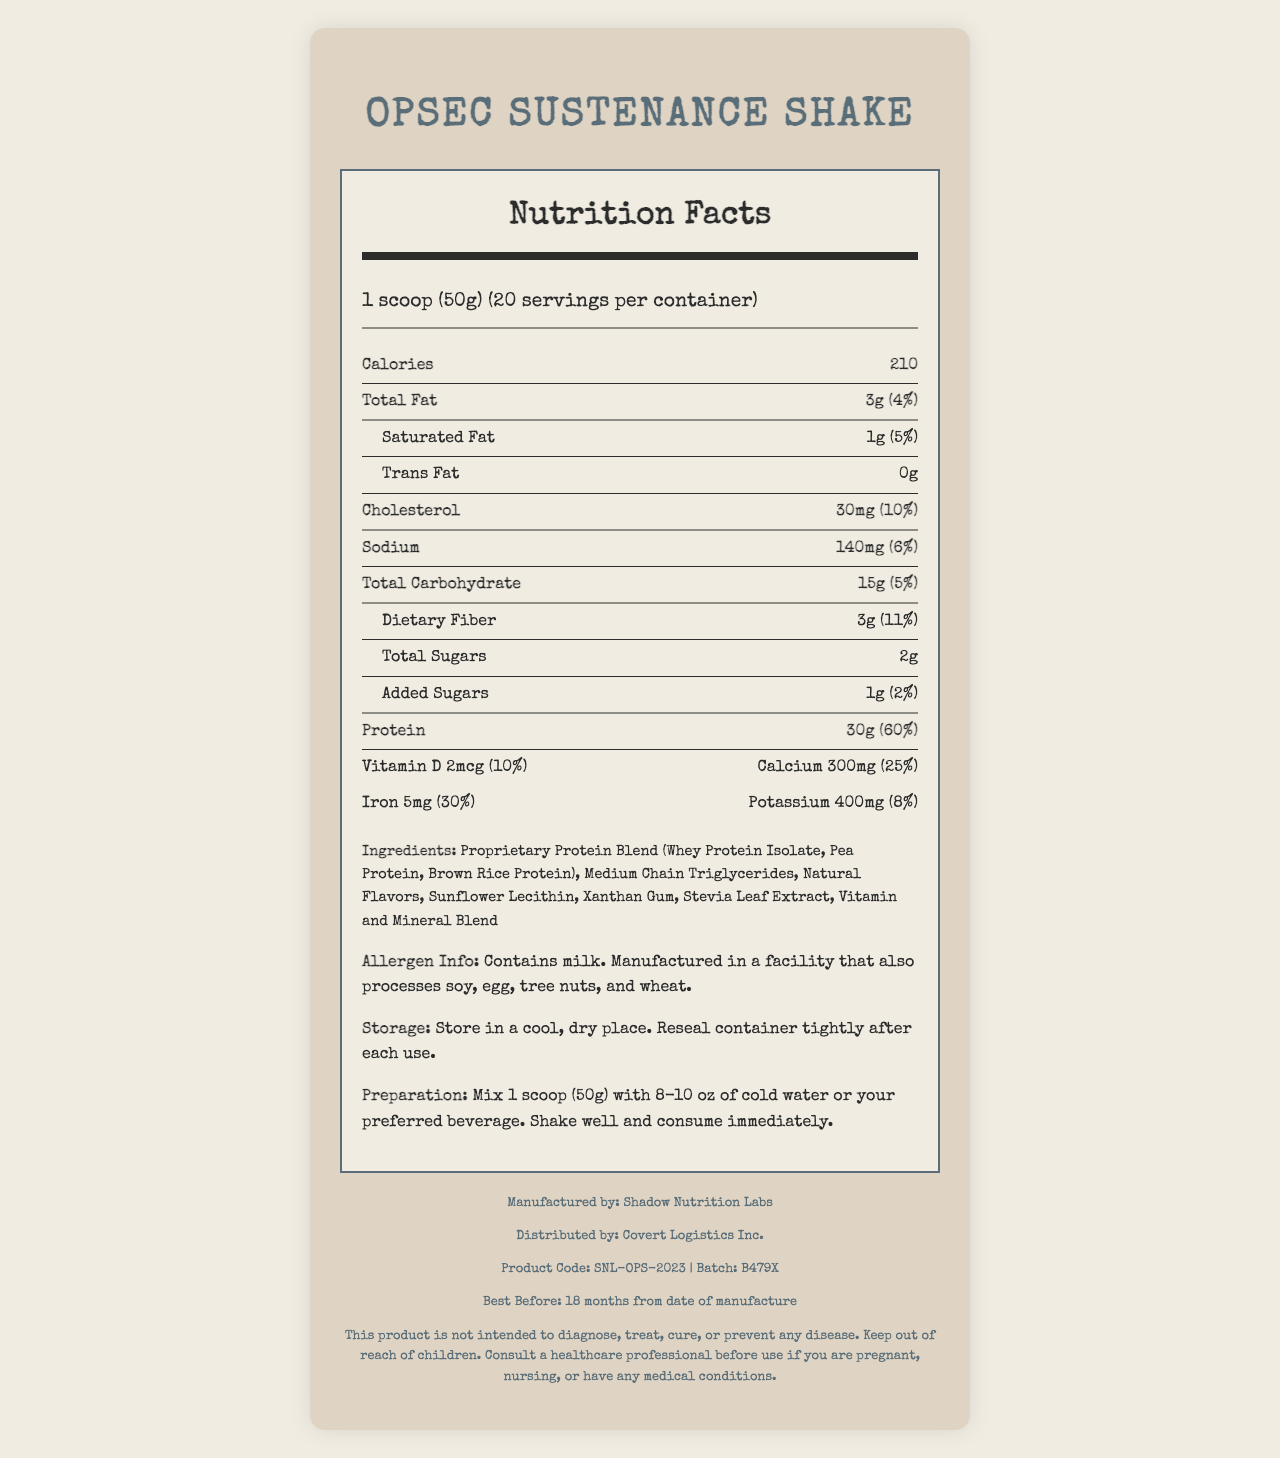what is the serving size for the OpSec Sustenance Shake? The serving size is stated as "1 scoop (50g)" in the serving info section.
Answer: 1 scoop (50g) how many servings are in one container of the OpSec Sustenance Shake? The document specifies that there are 20 servings per container.
Answer: 20 how many calories are in one serving of the OpSec Sustenance Shake? According to the bolded nutrient row, each serving contains 210 calories.
Answer: 210 what is the protein content in one serving of the OpSec Sustenance Shake? The protein content is listed as 30g in the bolded nutrient row for protein.
Answer: 30g what is the daily percentage value of vitamin B12 in this shake? The document states that the daily value percentage for vitamin B12 is 80%.
Answer: 80% which ingredient is not in the OpSec Sustenance Shake? A. Medium Chain Triglycerides B. Xanthan Gum C. Sucrose D. Stevia Leaf Extract The ingredients listed are Proprietary Protein Blend, Medium Chain Triglycerides, Natural Flavors, Sunflower Lecithin, Xanthan Gum, Stevia Leaf Extract, and Vitamin and Mineral Blend. Sucrose is not mentioned.
Answer: C what is the daily percentage value of vitamin E in one serving of the shake? The daily value percentage for vitamin E is noted as 70% in the vitamin-mineral section.
Answer: 70% does the OpSec Sustenance Shake contain added sugars? The document specifies that there are 1g of added sugars, which is 2% of the daily value.
Answer: Yes what is the company name that manufactures this product? According to the footer information, this product is manufactured by Shadow Nutrition Labs.
Answer: Shadow Nutrition Labs is there any trans fat in one serving of the OpSec Sustenance Shake? The document states that the amount of trans fat is 0g.
Answer: No describe the document's primary purpose and the kind of information it provides The document's primary purpose is to offer consumers detailed nutrition information for the OpSec Sustenance Shake. It lists all key nutrients, ingredients, and additional product information to help users understand its contents and how to use it.
Answer: The document serves as a Nutrition Facts Label for the OpSec Sustenance Shake. It provides comprehensive information about serving size, number of servings, and detailed nutrient content per serving, including macronutrients, vitamins, and minerals. The document also includes an ingredient list, allergen information, storage and preparation instructions, and manufacturer details. who is the distributor for the OpSec Sustenance Shake? The footer section of the document lists Covert Logistics Inc. as the distributor.
Answer: Covert Logistics Inc. what is the expiration date of the OpSec Sustenance Shake? The expiration date is given as "18 months from date of manufacture" in the footer.
Answer: 18 months from date of manufacture what is the total carbohydrate content of the OpSec Sustenance Shake? A. 10g B. 15g C. 20g D. 25g The document lists the total carbohydrate content as 15g.
Answer: B does the shake contain ingredients derived from tree nuts? The allergen info mentions that the product is manufactured in a facility that processes tree nuts, but it does not specify whether tree nuts are used in the shake itself.
Answer: Not enough information what is the amount of cholesterol in one serving? The document specifies that one serving contains 30mg of cholesterol.
Answer: 30mg how should this product be stored? The storage instructions section provides this storage information.
Answer: Store in a cool, dry place. Reseal container tightly after each use. what is the reason for consulting a healthcare professional before using this product? The legal disclaimer advises consulting a healthcare professional under these conditions.
Answer: if you are pregnant, nursing, or have any medical conditions is the OpSec Sustenance Shake intended to cure diseases? (True/False) The legal disclaimer clearly states that this product is not intended to diagnose, treat, cure, or prevent any disease.
Answer: False what is the primary purpose of the ingredient "Sunflower Lecithin" in this shake? The document does not provide detailed information about the specific roles of each ingredient.
Answer: Not enough information 